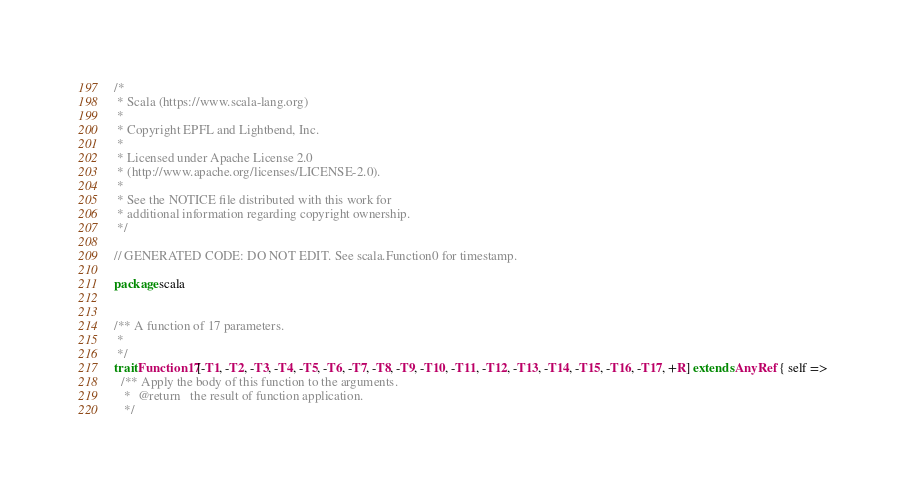<code> <loc_0><loc_0><loc_500><loc_500><_Scala_>/*
 * Scala (https://www.scala-lang.org)
 *
 * Copyright EPFL and Lightbend, Inc.
 *
 * Licensed under Apache License 2.0
 * (http://www.apache.org/licenses/LICENSE-2.0).
 *
 * See the NOTICE file distributed with this work for
 * additional information regarding copyright ownership.
 */

// GENERATED CODE: DO NOT EDIT. See scala.Function0 for timestamp.

package scala


/** A function of 17 parameters.
 *
 */
trait Function17[-T1, -T2, -T3, -T4, -T5, -T6, -T7, -T8, -T9, -T10, -T11, -T12, -T13, -T14, -T15, -T16, -T17, +R] extends AnyRef { self =>
  /** Apply the body of this function to the arguments.
   *  @return   the result of function application.
   */</code> 